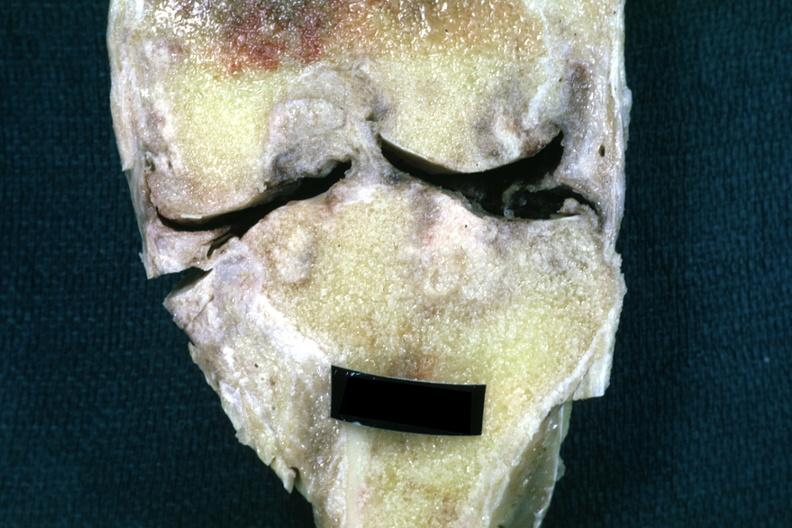s joints present?
Answer the question using a single word or phrase. Yes 